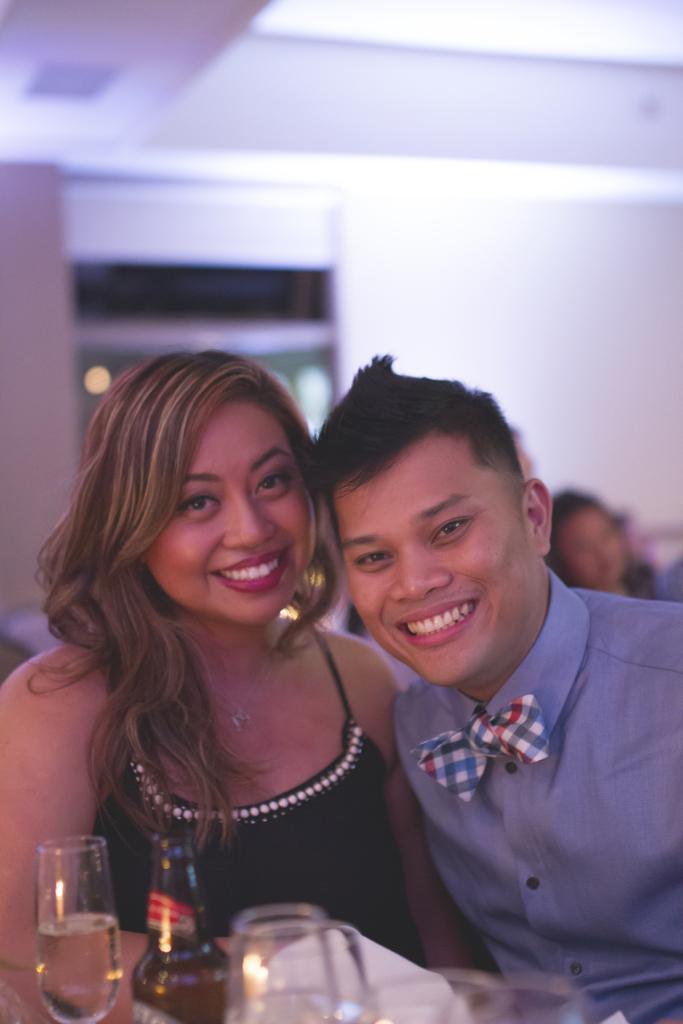In one or two sentences, can you explain what this image depicts? In this image there are two people sitting and smiling, there are glasses, there is a bottle, there is water in the glass, there is a wall, there is a roof. 